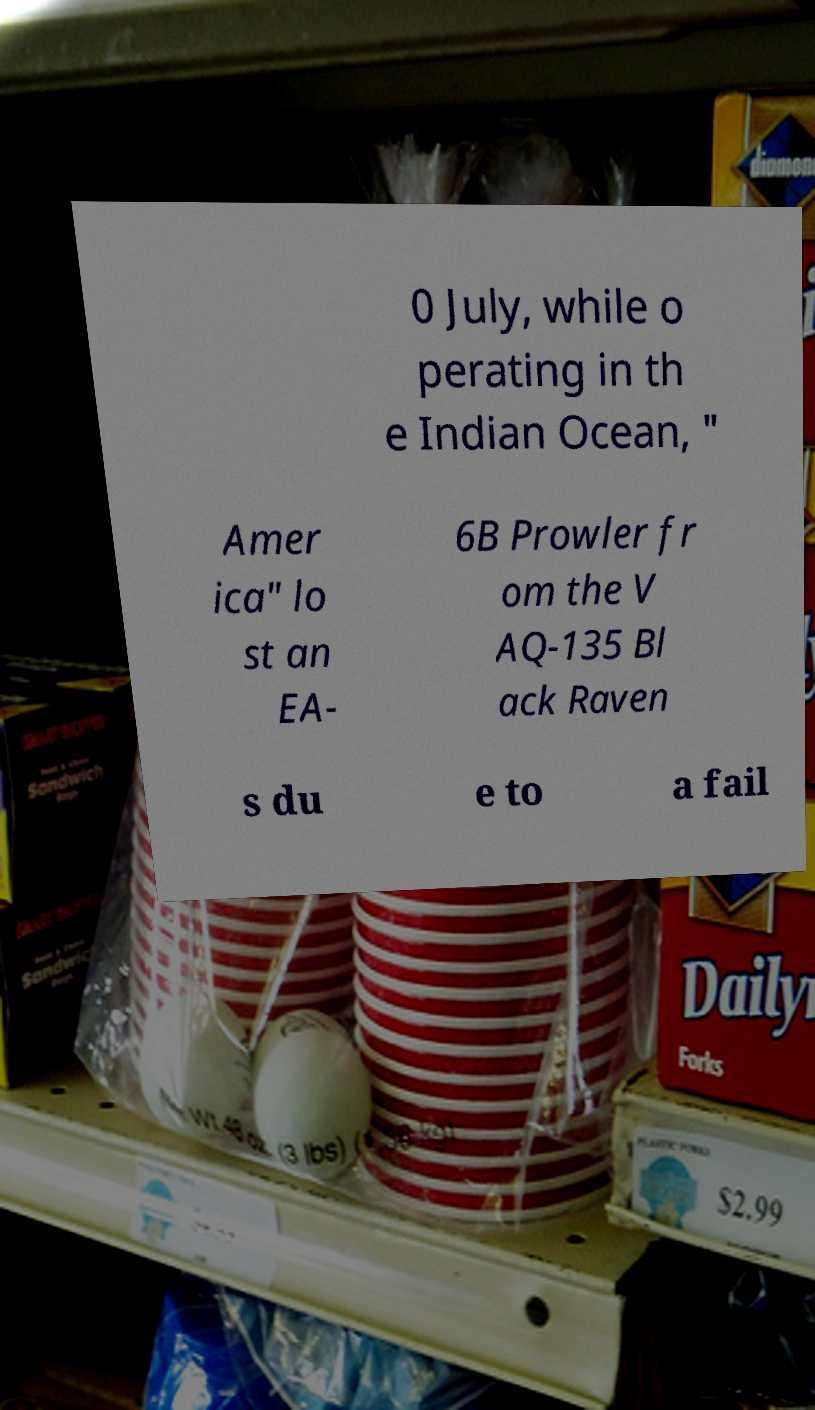Please read and relay the text visible in this image. What does it say? 0 July, while o perating in th e Indian Ocean, " Amer ica" lo st an EA- 6B Prowler fr om the V AQ-135 Bl ack Raven s du e to a fail 